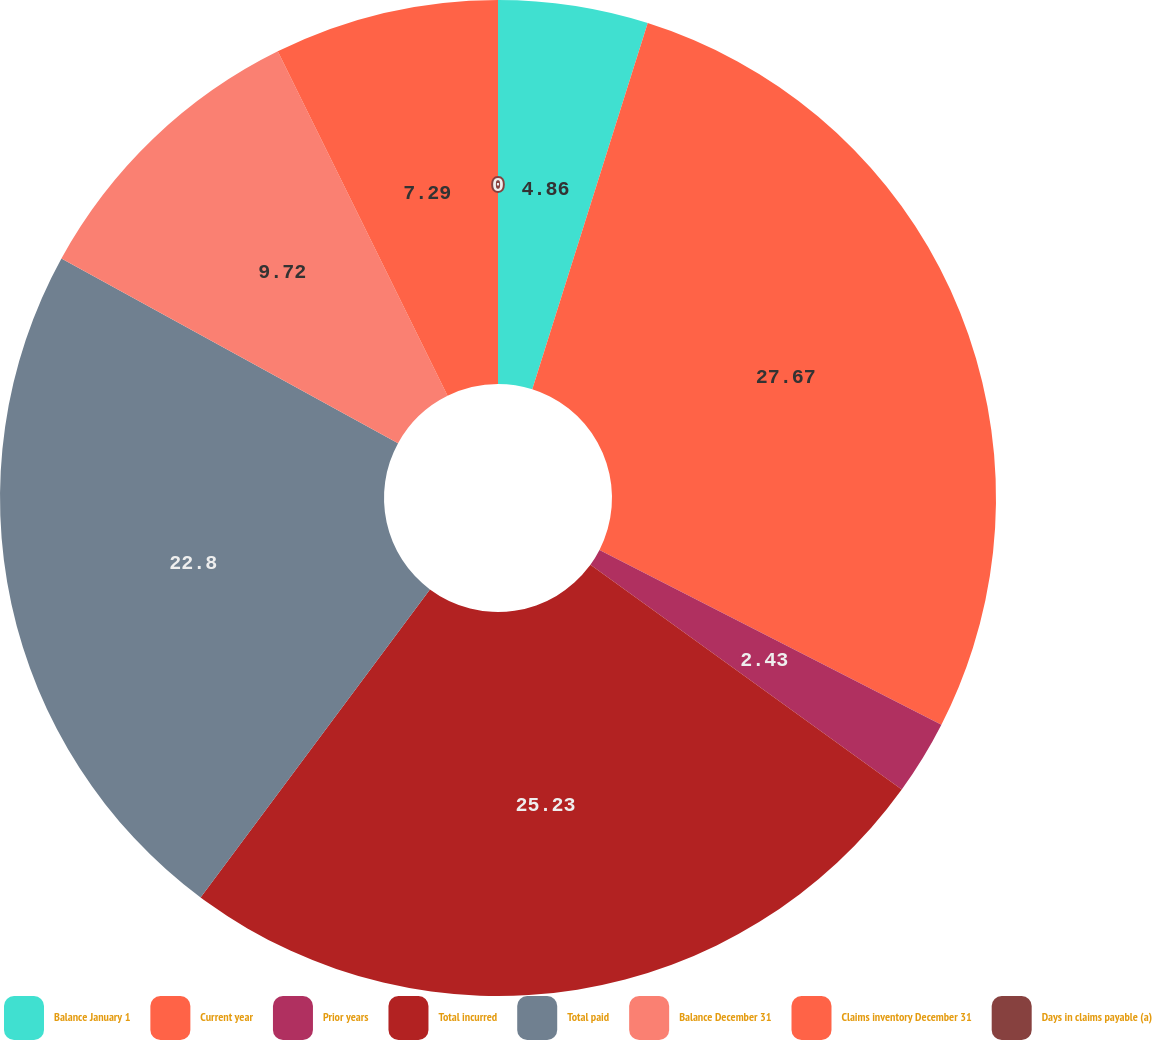<chart> <loc_0><loc_0><loc_500><loc_500><pie_chart><fcel>Balance January 1<fcel>Current year<fcel>Prior years<fcel>Total incurred<fcel>Total paid<fcel>Balance December 31<fcel>Claims inventory December 31<fcel>Days in claims payable (a)<nl><fcel>4.86%<fcel>27.66%<fcel>2.43%<fcel>25.23%<fcel>22.8%<fcel>9.72%<fcel>7.29%<fcel>0.0%<nl></chart> 